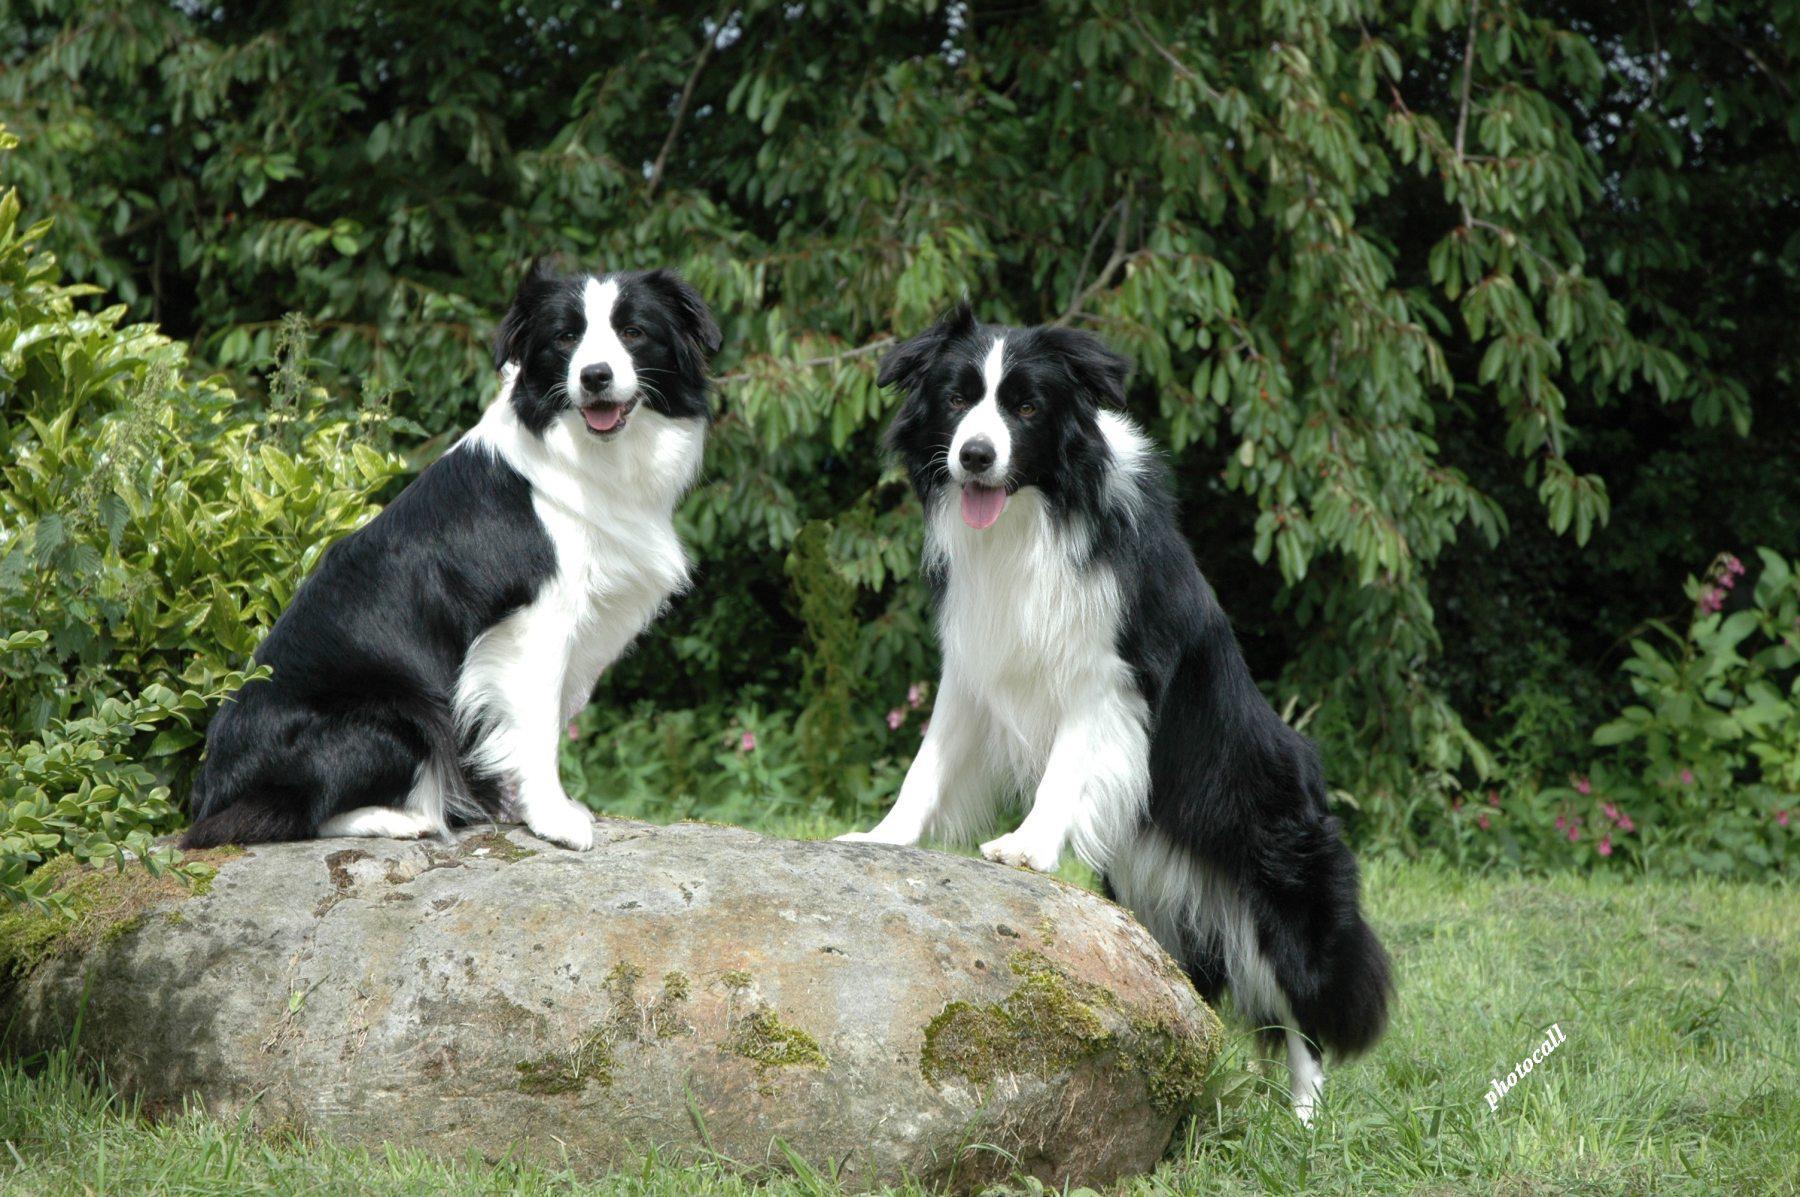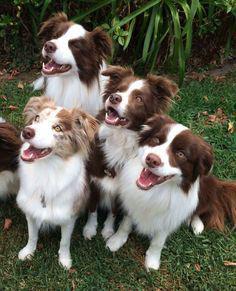The first image is the image on the left, the second image is the image on the right. Assess this claim about the two images: "There is a diagonal, rod-like dark object near at least one reclining dog.". Correct or not? Answer yes or no. No. 